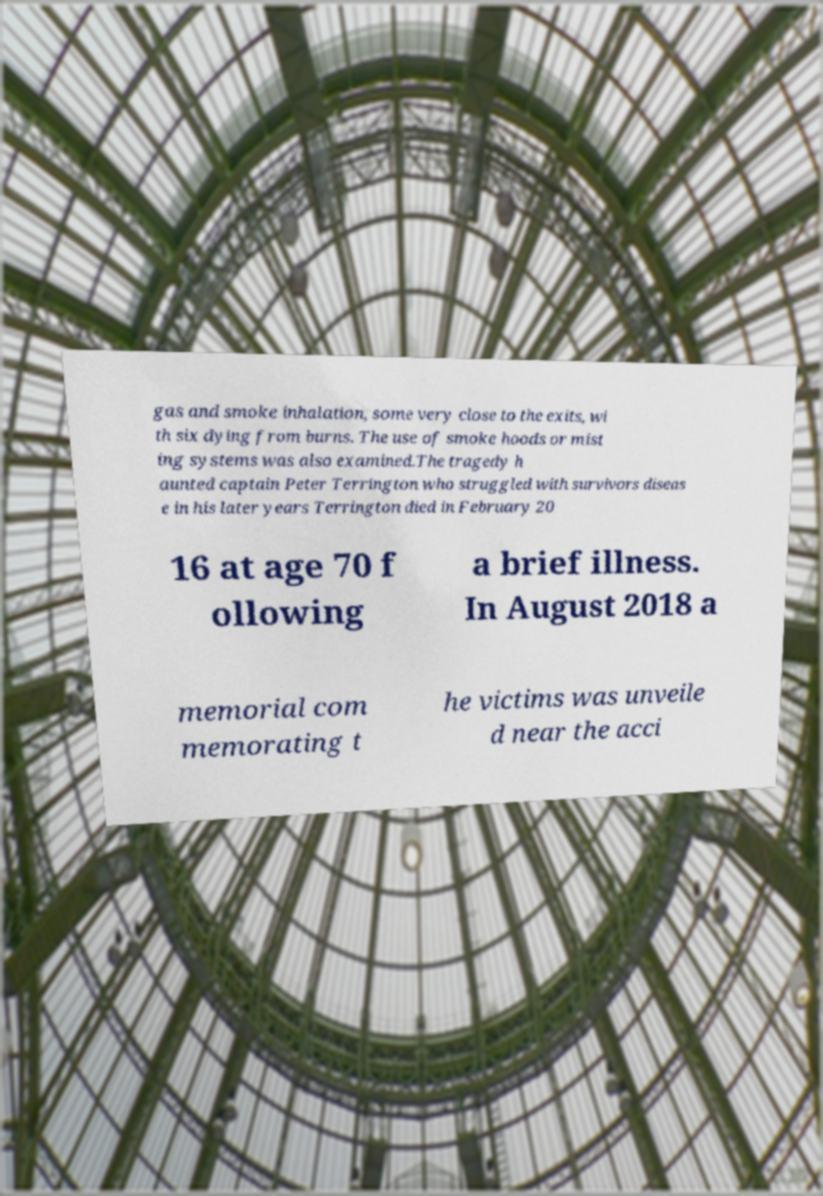There's text embedded in this image that I need extracted. Can you transcribe it verbatim? gas and smoke inhalation, some very close to the exits, wi th six dying from burns. The use of smoke hoods or mist ing systems was also examined.The tragedy h aunted captain Peter Terrington who struggled with survivors diseas e in his later years Terrington died in February 20 16 at age 70 f ollowing a brief illness. In August 2018 a memorial com memorating t he victims was unveile d near the acci 